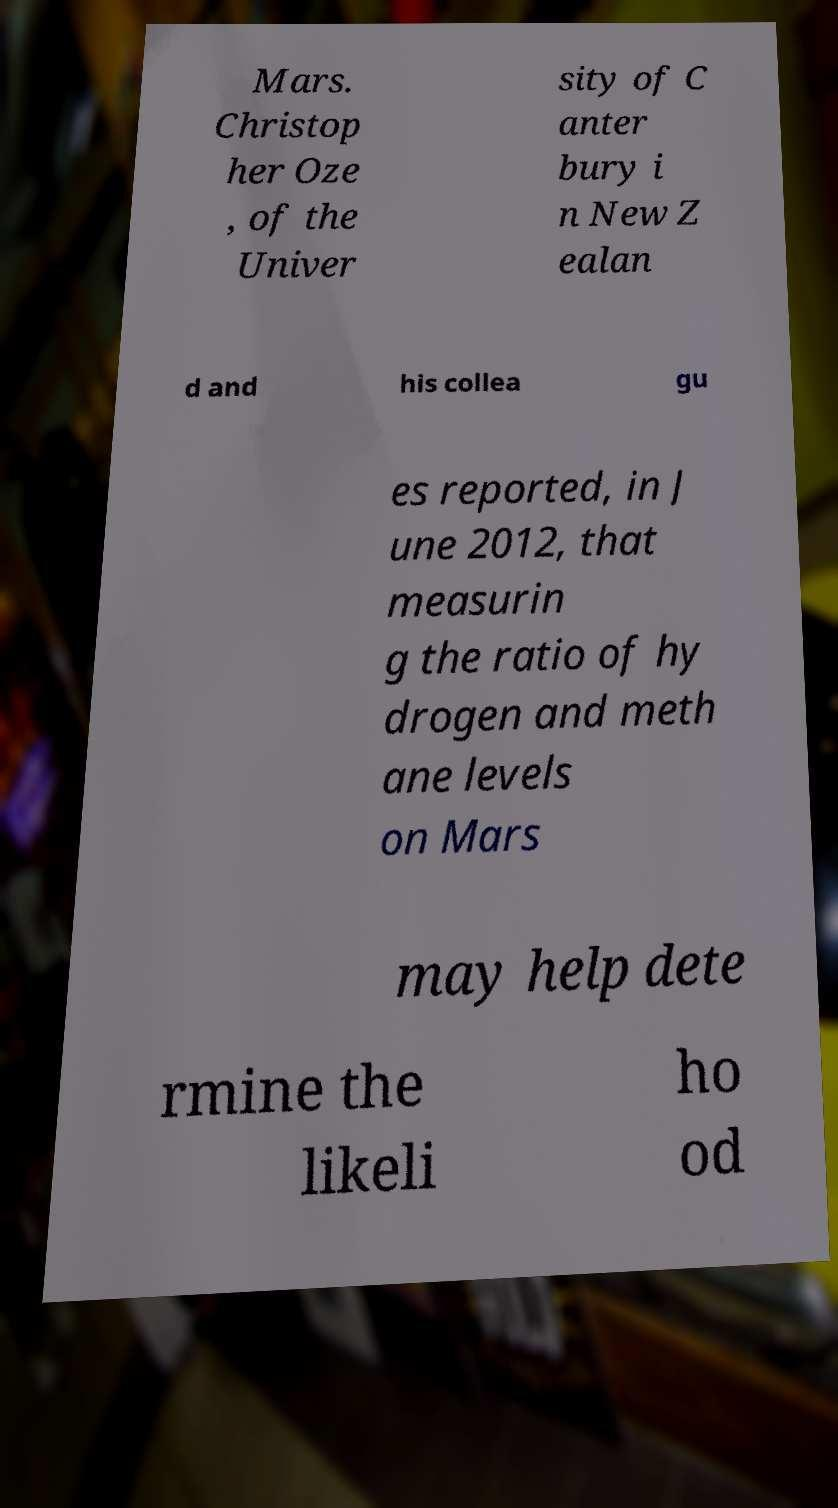What messages or text are displayed in this image? I need them in a readable, typed format. Mars. Christop her Oze , of the Univer sity of C anter bury i n New Z ealan d and his collea gu es reported, in J une 2012, that measurin g the ratio of hy drogen and meth ane levels on Mars may help dete rmine the likeli ho od 